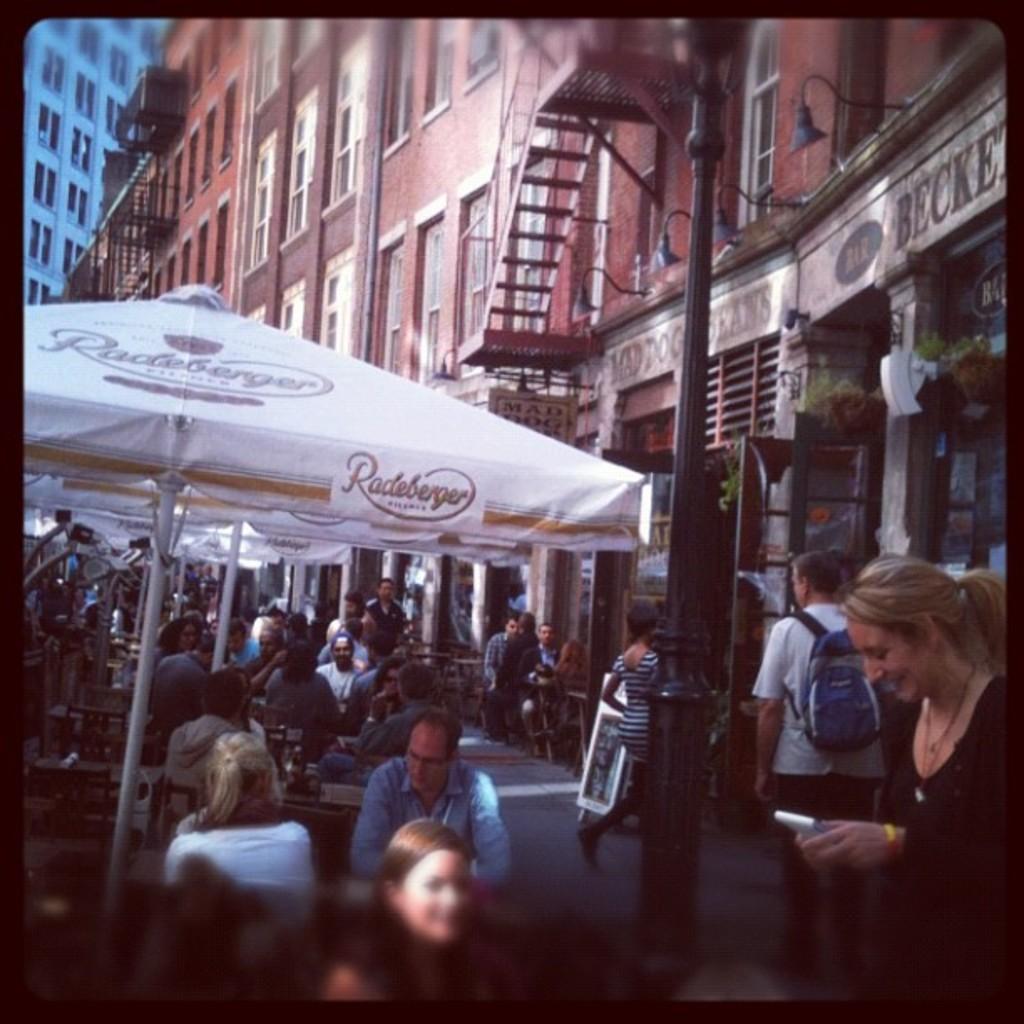Can you describe this image briefly? In this image on the road there are many people. There are few umbrellas here. In the background there are buildings. 